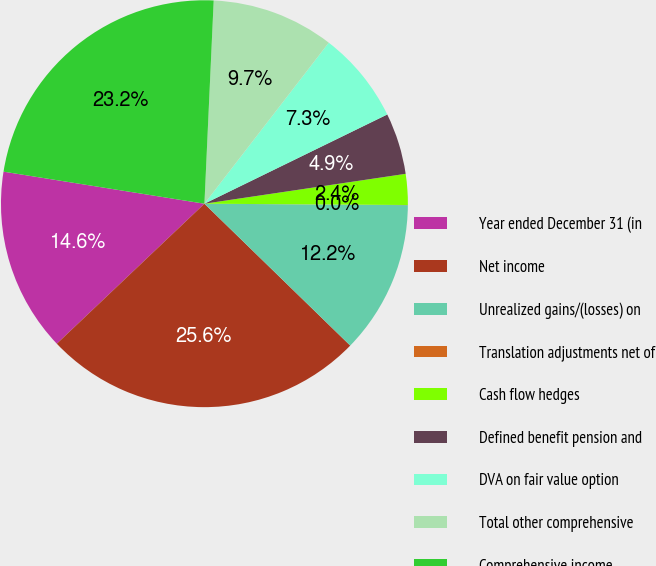Convert chart. <chart><loc_0><loc_0><loc_500><loc_500><pie_chart><fcel>Year ended December 31 (in<fcel>Net income<fcel>Unrealized gains/(losses) on<fcel>Translation adjustments net of<fcel>Cash flow hedges<fcel>Defined benefit pension and<fcel>DVA on fair value option<fcel>Total other comprehensive<fcel>Comprehensive income<nl><fcel>14.6%<fcel>25.64%<fcel>12.17%<fcel>0.01%<fcel>2.45%<fcel>4.88%<fcel>7.31%<fcel>9.74%<fcel>23.21%<nl></chart> 